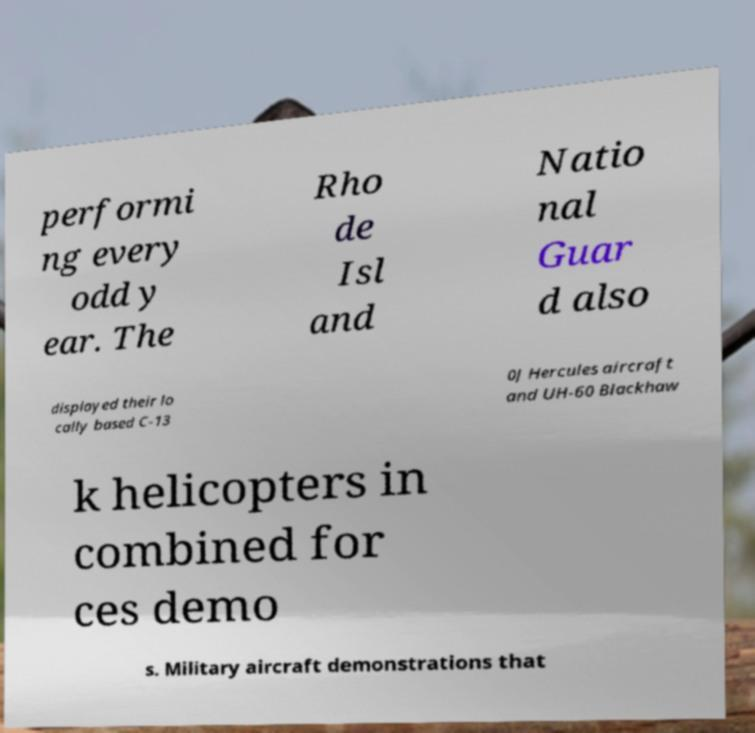Please identify and transcribe the text found in this image. performi ng every odd y ear. The Rho de Isl and Natio nal Guar d also displayed their lo cally based C-13 0J Hercules aircraft and UH-60 Blackhaw k helicopters in combined for ces demo s. Military aircraft demonstrations that 